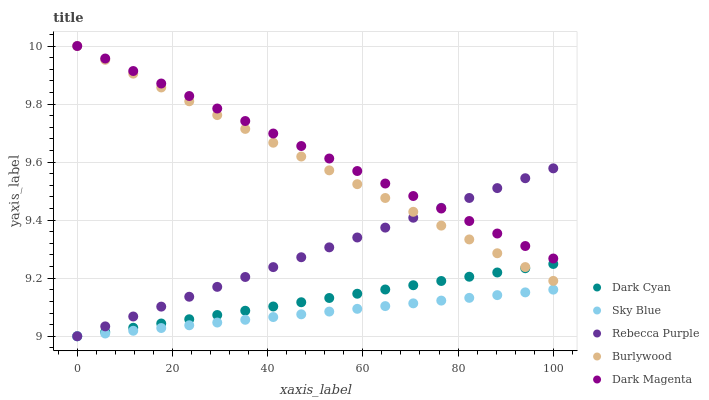Does Sky Blue have the minimum area under the curve?
Answer yes or no. Yes. Does Dark Magenta have the maximum area under the curve?
Answer yes or no. Yes. Does Rebecca Purple have the minimum area under the curve?
Answer yes or no. No. Does Rebecca Purple have the maximum area under the curve?
Answer yes or no. No. Is Dark Magenta the smoothest?
Answer yes or no. Yes. Is Burlywood the roughest?
Answer yes or no. Yes. Is Sky Blue the smoothest?
Answer yes or no. No. Is Sky Blue the roughest?
Answer yes or no. No. Does Dark Cyan have the lowest value?
Answer yes or no. Yes. Does Burlywood have the lowest value?
Answer yes or no. No. Does Dark Magenta have the highest value?
Answer yes or no. Yes. Does Rebecca Purple have the highest value?
Answer yes or no. No. Is Dark Cyan less than Dark Magenta?
Answer yes or no. Yes. Is Dark Magenta greater than Sky Blue?
Answer yes or no. Yes. Does Rebecca Purple intersect Burlywood?
Answer yes or no. Yes. Is Rebecca Purple less than Burlywood?
Answer yes or no. No. Is Rebecca Purple greater than Burlywood?
Answer yes or no. No. Does Dark Cyan intersect Dark Magenta?
Answer yes or no. No. 